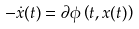Convert formula to latex. <formula><loc_0><loc_0><loc_500><loc_500>- \dot { x } ( t ) = \partial \phi \left ( t , x ( t ) \right )</formula> 